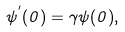<formula> <loc_0><loc_0><loc_500><loc_500>\psi ^ { ^ { \prime } } ( 0 ) = \gamma \psi ( 0 ) ,</formula> 